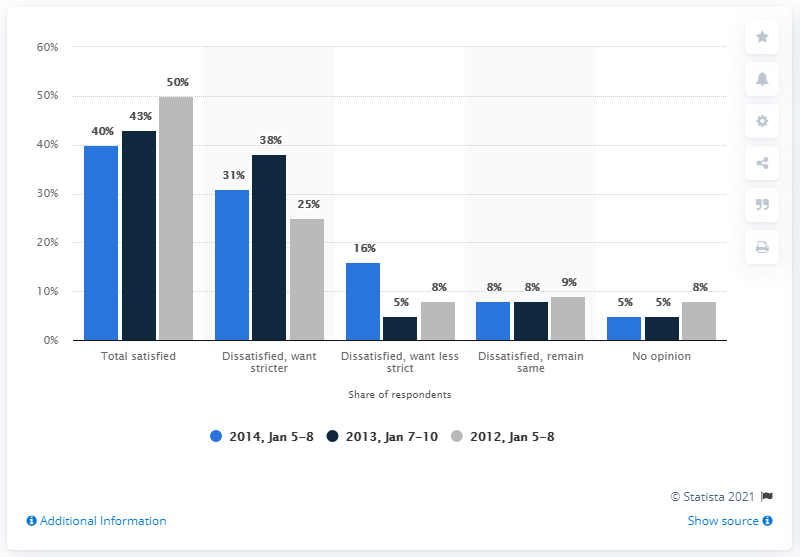Give some essential details in this illustration. The blue bar showing 16% indicates dissatisfaction with a preference for less strict requirements. The average score in the No Opinion category is 6. 